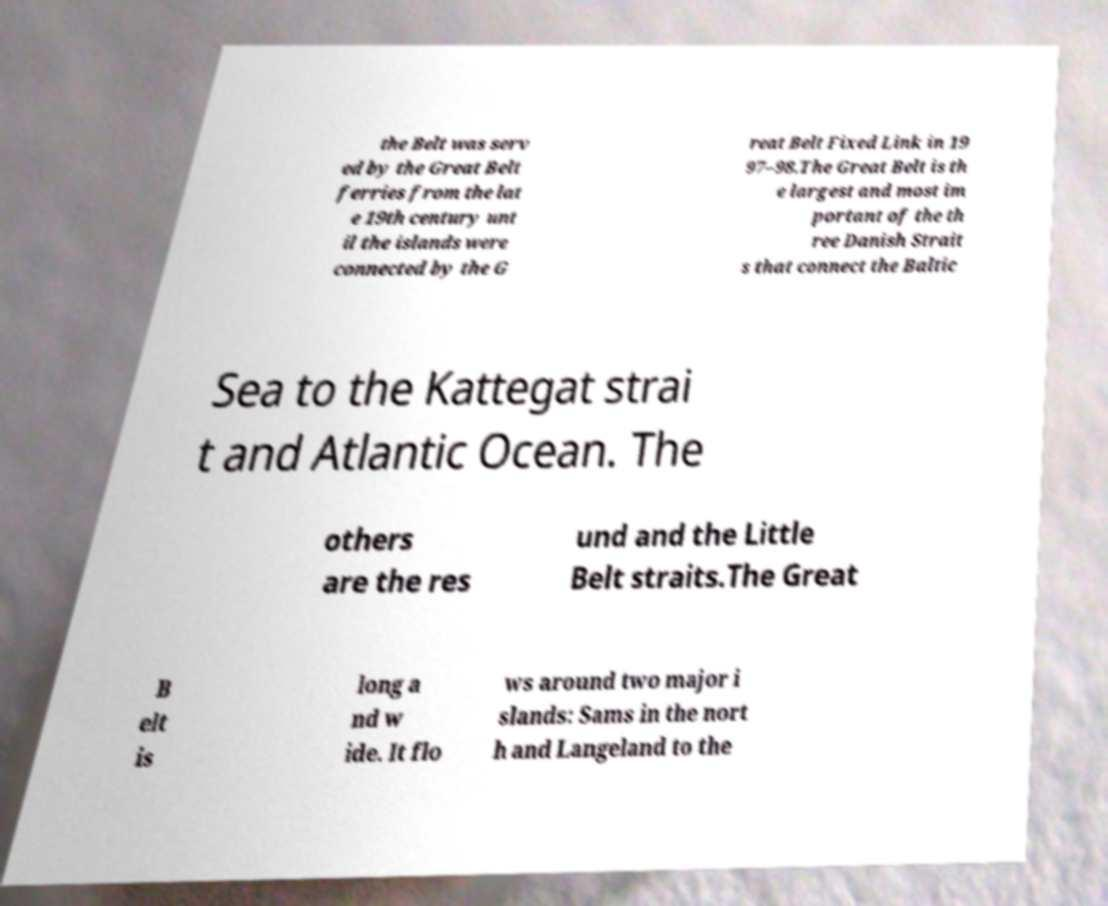Please read and relay the text visible in this image. What does it say? the Belt was serv ed by the Great Belt ferries from the lat e 19th century unt il the islands were connected by the G reat Belt Fixed Link in 19 97–98.The Great Belt is th e largest and most im portant of the th ree Danish Strait s that connect the Baltic Sea to the Kattegat strai t and Atlantic Ocean. The others are the res und and the Little Belt straits.The Great B elt is long a nd w ide. It flo ws around two major i slands: Sams in the nort h and Langeland to the 